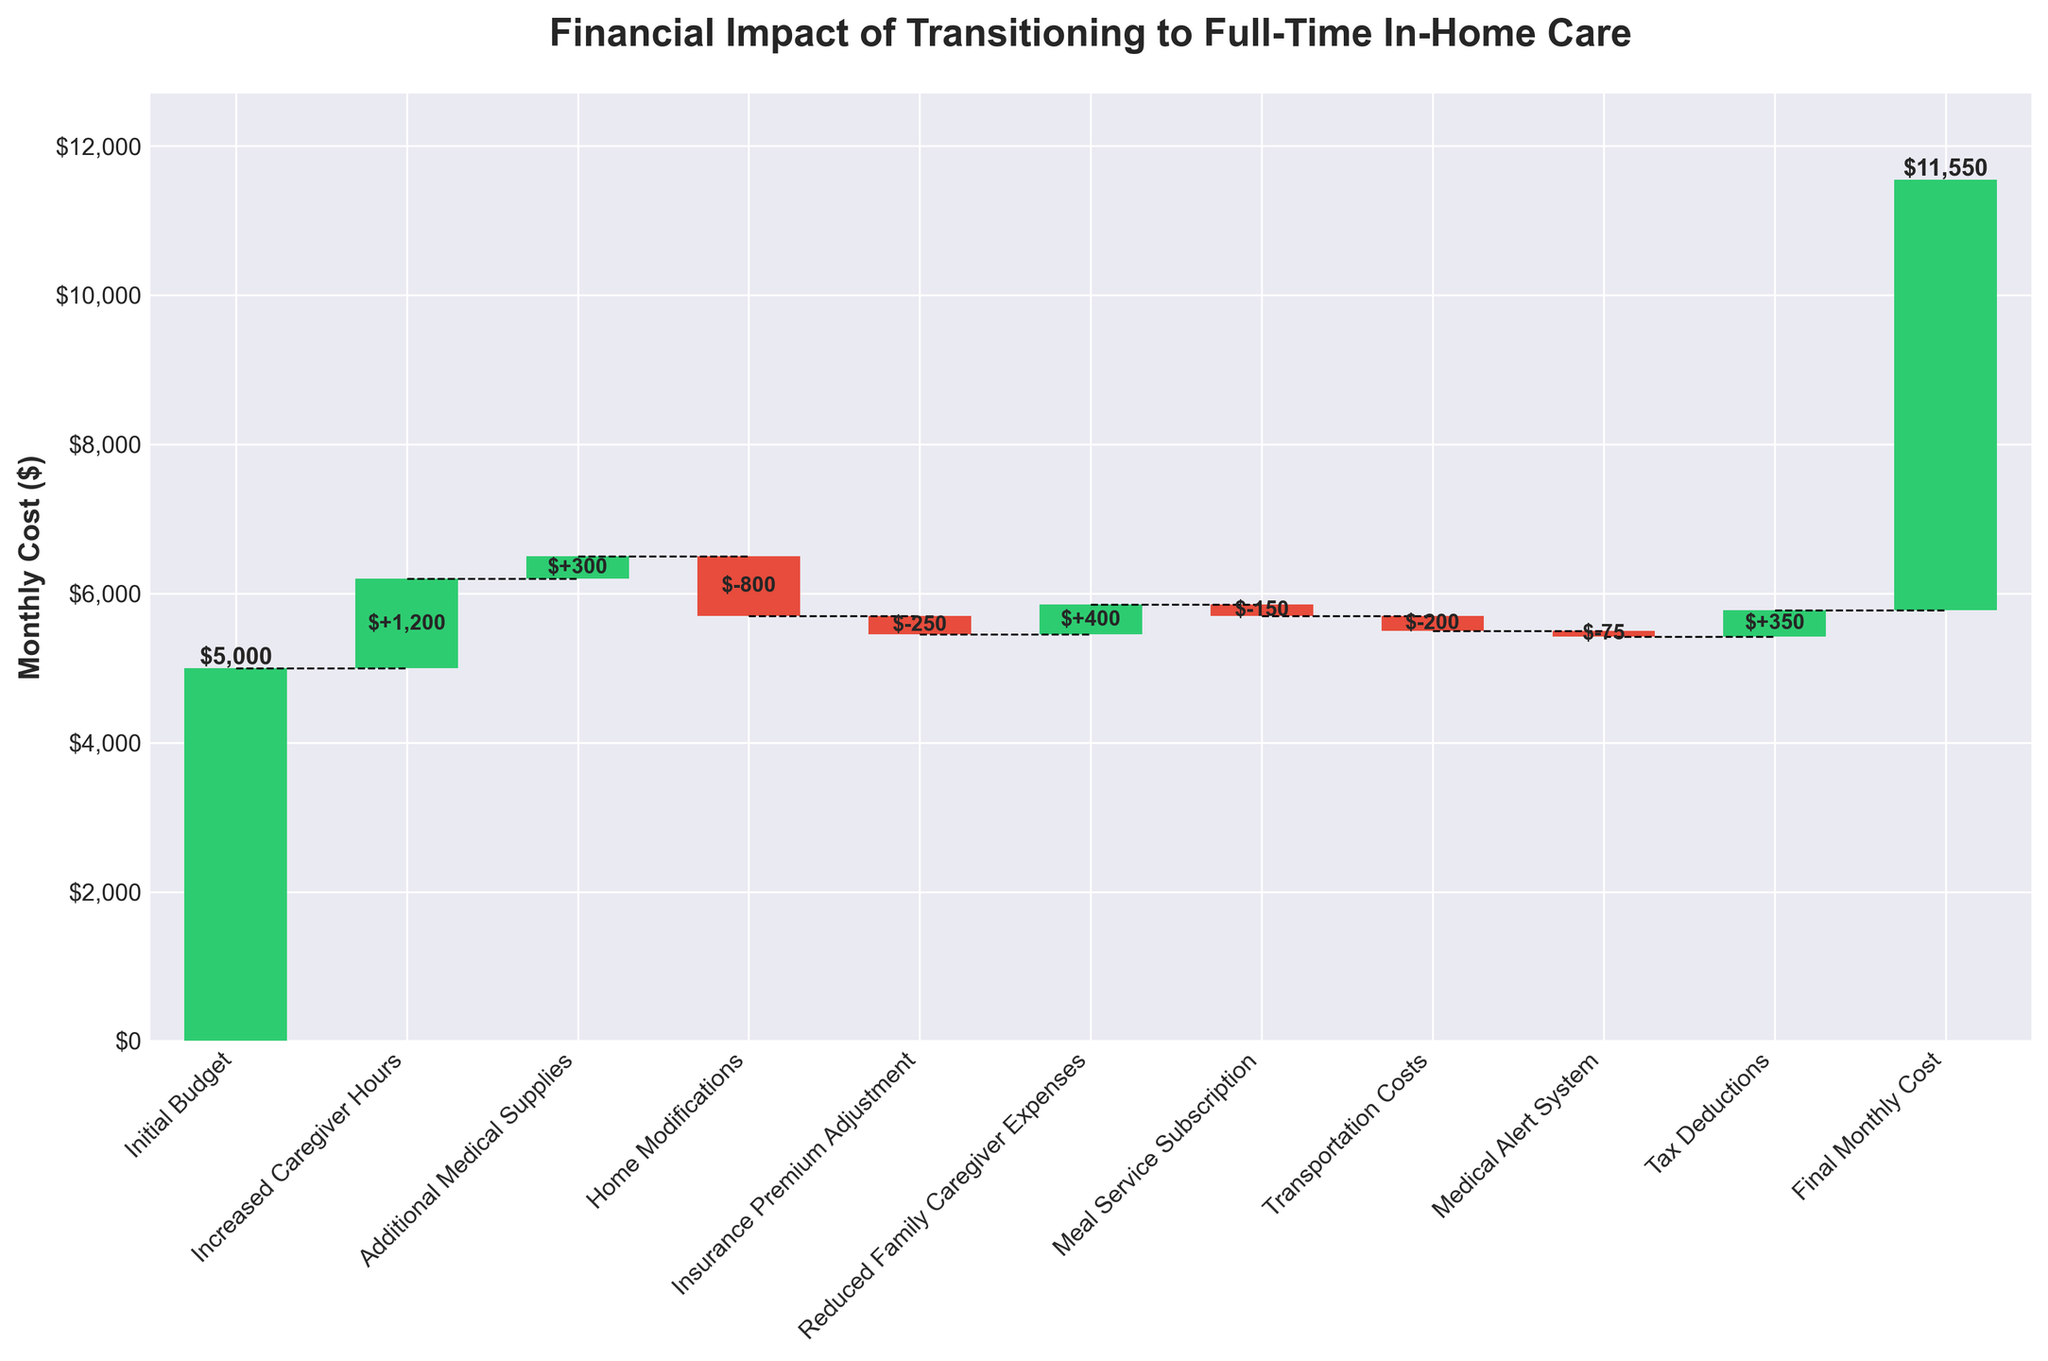What's the title of the chart? The title of the chart is displayed at the top and reads: "Financial Impact of Transitioning to Full-Time In-Home Care"
Answer: Financial Impact of Transitioning to Full-Time In-Home Care How many data points are shown in the figure? The chart includes data from the initial budget to the final monthly cost, counting all individual elements. Each category listed in the x-axis represents a data point, totaling 11 data points.
Answer: 11 What is the final monthly cost? The final monthly cost is indicated at the end of the chart by the last cumulative value. It's displayed directly on the bar as $5,775.
Answer: $5,775 What is the cumulative effect of increased caregiver hours and additional medical supplies on the budget? To find the cumulative effect, sum the individual values of increased caregiver hours (+1200) and additional medical supplies (+300). $1200 + $300 = $1500.
Answer: $1500 Which category has the largest positive impact on the budget? By assessing the height of the bars, the Largest positive impact is from "Increased Caregiver Hours" at +$1200.
Answer: Increased Caregiver Hours Which category contributes the most to the reduction of the budget? The category with the tallest negative bar is "Home Modifications" with a value of -$800.
Answer: Home Modifications What effect did tax deductions have on the overall cost? Tax deductions are listed and shown as the second-to-last bar, adding positively (saving) to the budget by $350.
Answer: $350 How does the impact of meal service subscription compare to transportation costs? Both categories have negative impacts, with meal service subscription at -$150 and transportation costs at -$200. Since -$150 is greater than -$200, meal service subscription has a lesser negative impact.
Answer: Meal service subscription has a lesser negative impact What is the net change from the initial budget to the final cost? Net change is calculated by subtracting the initial budget ($5000) from the final monthly cost ($5775). $5775 - $5000 = $775.
Answer: $775 How much did insurance premium adjustment and tax deductions collectively impact the budget? Sum the values for insurance premium adjustment (-$250) and tax deductions (+$350). The collective impact is $350 - $250 = $100.
Answer: $100 